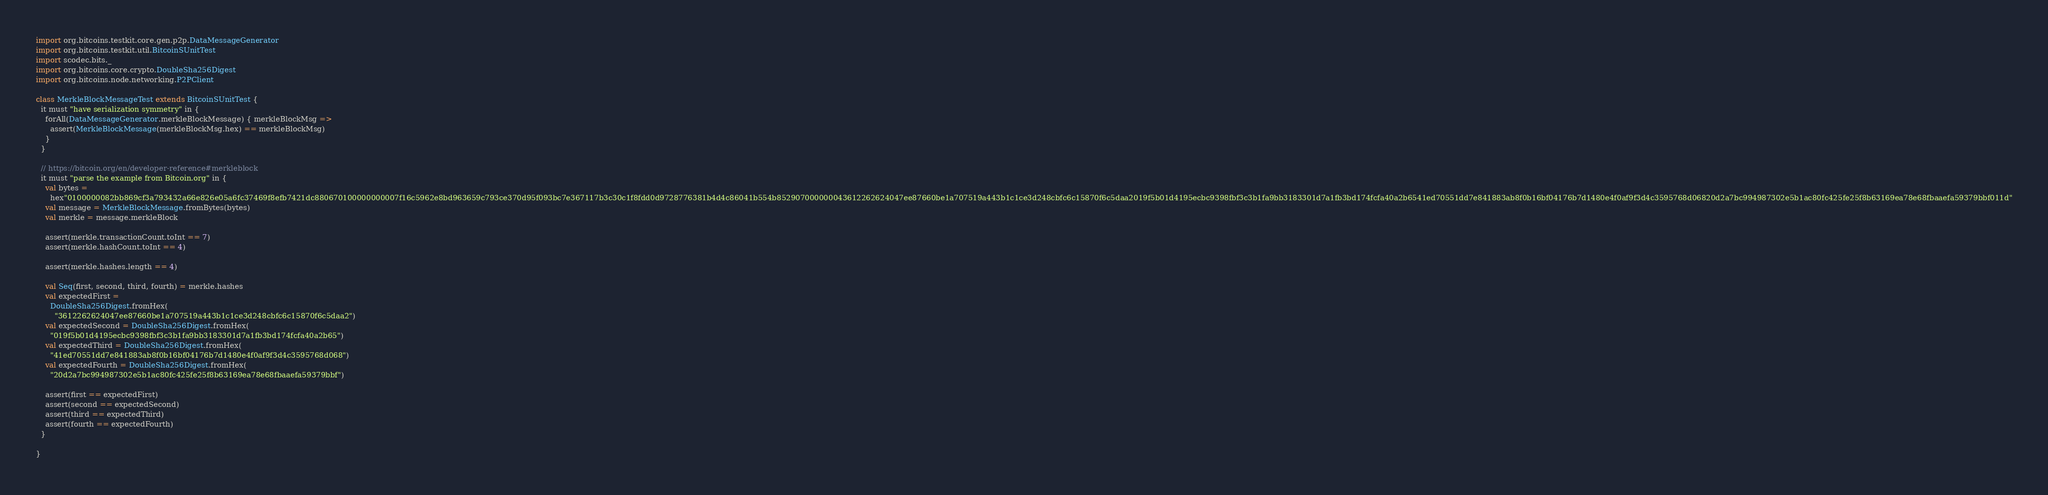<code> <loc_0><loc_0><loc_500><loc_500><_Scala_>import org.bitcoins.testkit.core.gen.p2p.DataMessageGenerator
import org.bitcoins.testkit.util.BitcoinSUnitTest
import scodec.bits._
import org.bitcoins.core.crypto.DoubleSha256Digest
import org.bitcoins.node.networking.P2PClient

class MerkleBlockMessageTest extends BitcoinSUnitTest {
  it must "have serialization symmetry" in {
    forAll(DataMessageGenerator.merkleBlockMessage) { merkleBlockMsg =>
      assert(MerkleBlockMessage(merkleBlockMsg.hex) == merkleBlockMsg)
    }
  }

  // https://bitcoin.org/en/developer-reference#merkleblock
  it must "parse the example from Bitcoin.org" in {
    val bytes =
      hex"0100000082bb869cf3a793432a66e826e05a6fc37469f8efb7421dc880670100000000007f16c5962e8bd963659c793ce370d95f093bc7e367117b3c30c1f8fdd0d9728776381b4d4c86041b554b852907000000043612262624047ee87660be1a707519a443b1c1ce3d248cbfc6c15870f6c5daa2019f5b01d4195ecbc9398fbf3c3b1fa9bb3183301d7a1fb3bd174fcfa40a2b6541ed70551dd7e841883ab8f0b16bf04176b7d1480e4f0af9f3d4c3595768d06820d2a7bc994987302e5b1ac80fc425fe25f8b63169ea78e68fbaaefa59379bbf011d"
    val message = MerkleBlockMessage.fromBytes(bytes)
    val merkle = message.merkleBlock

    assert(merkle.transactionCount.toInt == 7)
    assert(merkle.hashCount.toInt == 4)

    assert(merkle.hashes.length == 4)

    val Seq(first, second, third, fourth) = merkle.hashes
    val expectedFirst =
      DoubleSha256Digest.fromHex(
        "3612262624047ee87660be1a707519a443b1c1ce3d248cbfc6c15870f6c5daa2")
    val expectedSecond = DoubleSha256Digest.fromHex(
      "019f5b01d4195ecbc9398fbf3c3b1fa9bb3183301d7a1fb3bd174fcfa40a2b65")
    val expectedThird = DoubleSha256Digest.fromHex(
      "41ed70551dd7e841883ab8f0b16bf04176b7d1480e4f0af9f3d4c3595768d068")
    val expectedFourth = DoubleSha256Digest.fromHex(
      "20d2a7bc994987302e5b1ac80fc425fe25f8b63169ea78e68fbaaefa59379bbf")

    assert(first == expectedFirst)
    assert(second == expectedSecond)
    assert(third == expectedThird)
    assert(fourth == expectedFourth)
  }

}
</code> 